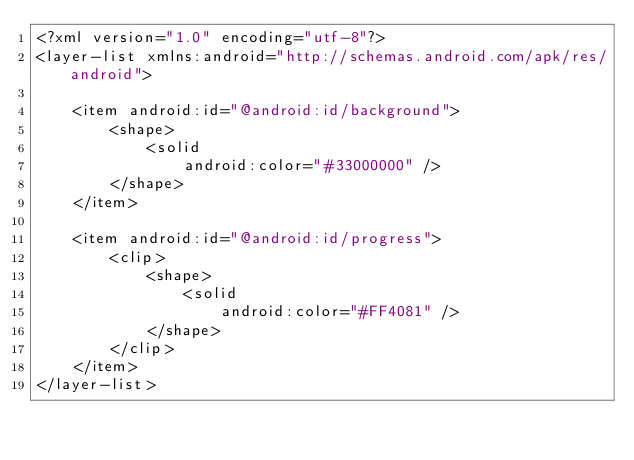<code> <loc_0><loc_0><loc_500><loc_500><_XML_><?xml version="1.0" encoding="utf-8"?>
<layer-list xmlns:android="http://schemas.android.com/apk/res/android">

    <item android:id="@android:id/background">
        <shape>
            <solid
                android:color="#33000000" />
        </shape>
    </item>

    <item android:id="@android:id/progress">
        <clip>
            <shape>
                <solid
                    android:color="#FF4081" />
            </shape>
        </clip>
    </item>
</layer-list></code> 